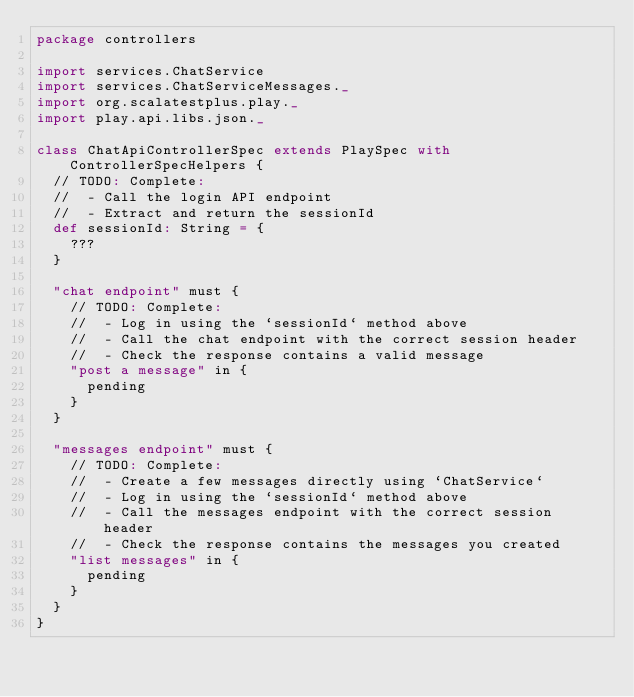<code> <loc_0><loc_0><loc_500><loc_500><_Scala_>package controllers

import services.ChatService
import services.ChatServiceMessages._
import org.scalatestplus.play._
import play.api.libs.json._

class ChatApiControllerSpec extends PlaySpec with ControllerSpecHelpers {
  // TODO: Complete:
  //  - Call the login API endpoint
  //  - Extract and return the sessionId
  def sessionId: String = {
    ???
  }

  "chat endpoint" must {
    // TODO: Complete:
    //  - Log in using the `sessionId` method above
    //  - Call the chat endpoint with the correct session header
    //  - Check the response contains a valid message
    "post a message" in {
      pending
    }
  }

  "messages endpoint" must {
    // TODO: Complete:
    //  - Create a few messages directly using `ChatService`
    //  - Log in using the `sessionId` method above
    //  - Call the messages endpoint with the correct session header
    //  - Check the response contains the messages you created
    "list messages" in {
      pending
    }
  }
}</code> 